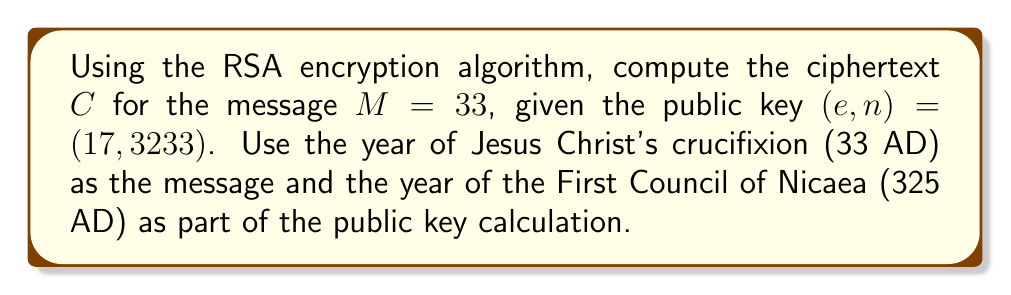Provide a solution to this math problem. To encrypt a message $M$ using RSA, we need to compute:

$C \equiv M^e \pmod{n}$

Where:
- $M = 33$ (year of Christ's crucifixion)
- $e = 17$ (part of the public key)
- $n = 3233$ (part of the public key, related to the year 325 AD)

We need to calculate $33^{17} \pmod{3233}$. This is a large exponentiation, so we'll use the square-and-multiply algorithm:

1) Convert 17 to binary: $17_{10} = 10001_2$

2) Initialize: $result = 1$

3) For each bit in 17 (from left to right):
   a) Square the result: $result = result^2 \pmod{3233}$
   b) If the bit is 1, multiply by 33: $result = result \cdot 33 \pmod{3233}$

Step-by-step:
1) $1^2 \cdot 33 \equiv 33 \pmod{3233}$
2) $33^2 \equiv 1089 \pmod{3233}$
3) $1089^2 \equiv 825 \pmod{3233}$
4) $825^2 \equiv 2307 \pmod{3233}$
5) $2307^2 \cdot 33 \equiv 2475 \pmod{3233}$

Therefore, $C = 33^{17} \pmod{3233} \equiv 2475 \pmod{3233}$
Answer: $C = 2475$ 